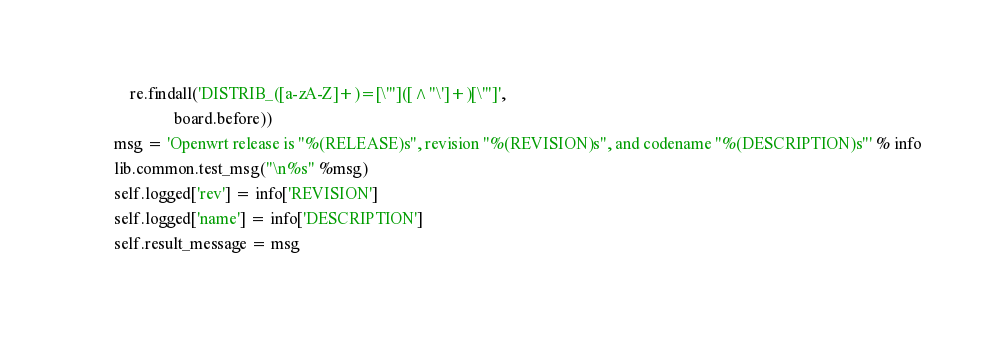<code> <loc_0><loc_0><loc_500><loc_500><_Python_>            re.findall('DISTRIB_([a-zA-Z]+)=[\'"]([^"\']+)[\'"]',
                       board.before))
        msg = 'Openwrt release is "%(RELEASE)s", revision "%(REVISION)s", and codename "%(DESCRIPTION)s"' % info
        lib.common.test_msg("\n%s" %msg)
        self.logged['rev'] = info['REVISION']
        self.logged['name'] = info['DESCRIPTION']
        self.result_message = msg
</code> 